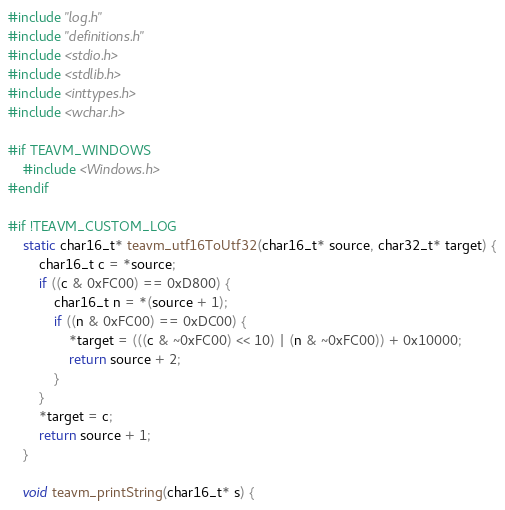Convert code to text. <code><loc_0><loc_0><loc_500><loc_500><_C_>#include "log.h"
#include "definitions.h"
#include <stdio.h>
#include <stdlib.h>
#include <inttypes.h>
#include <wchar.h>

#if TEAVM_WINDOWS
    #include <Windows.h>
#endif

#if !TEAVM_CUSTOM_LOG
    static char16_t* teavm_utf16ToUtf32(char16_t* source, char32_t* target) {
        char16_t c = *source;
        if ((c & 0xFC00) == 0xD800) {
            char16_t n = *(source + 1);
            if ((n & 0xFC00) == 0xDC00) {
                *target = (((c & ~0xFC00) << 10) | (n & ~0xFC00)) + 0x10000;
                return source + 2;
            }
        }
        *target = c;
        return source + 1;
    }

    void teavm_printString(char16_t* s) {</code> 